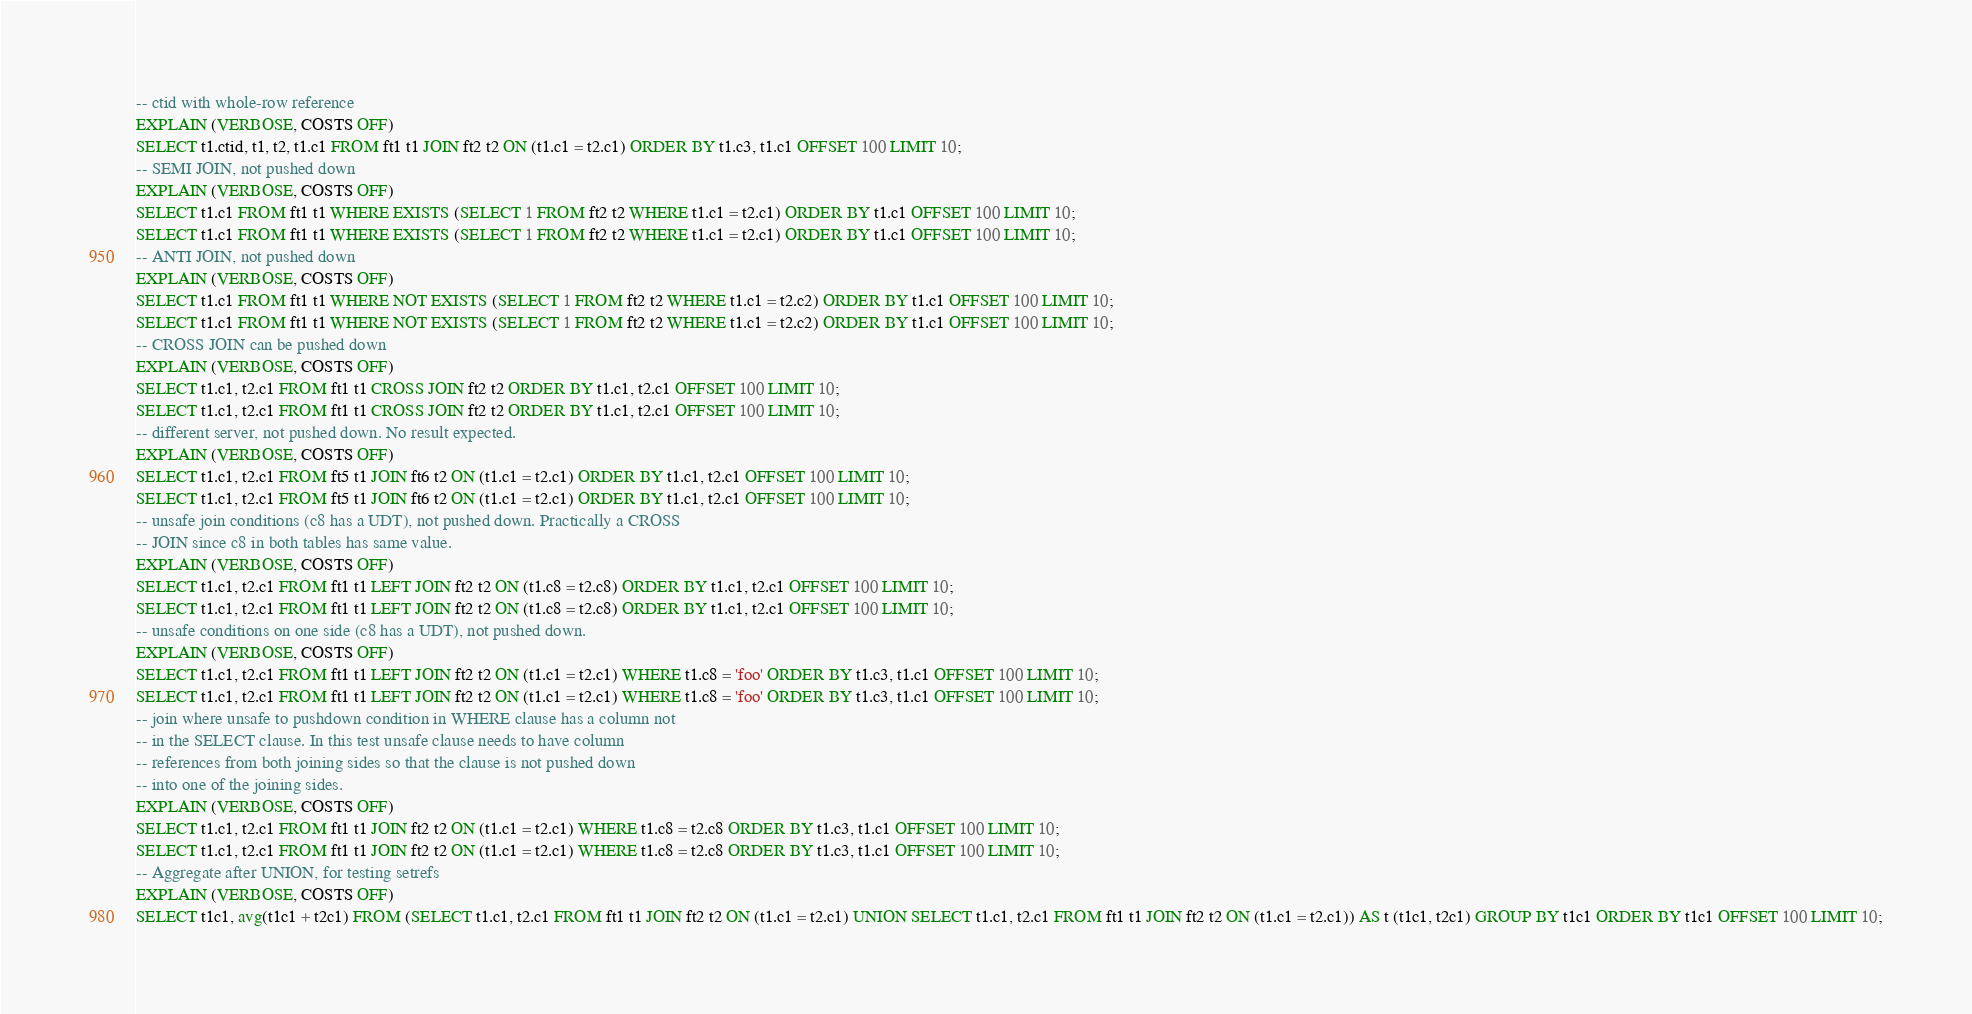<code> <loc_0><loc_0><loc_500><loc_500><_SQL_>-- ctid with whole-row reference
EXPLAIN (VERBOSE, COSTS OFF)
SELECT t1.ctid, t1, t2, t1.c1 FROM ft1 t1 JOIN ft2 t2 ON (t1.c1 = t2.c1) ORDER BY t1.c3, t1.c1 OFFSET 100 LIMIT 10;
-- SEMI JOIN, not pushed down
EXPLAIN (VERBOSE, COSTS OFF)
SELECT t1.c1 FROM ft1 t1 WHERE EXISTS (SELECT 1 FROM ft2 t2 WHERE t1.c1 = t2.c1) ORDER BY t1.c1 OFFSET 100 LIMIT 10;
SELECT t1.c1 FROM ft1 t1 WHERE EXISTS (SELECT 1 FROM ft2 t2 WHERE t1.c1 = t2.c1) ORDER BY t1.c1 OFFSET 100 LIMIT 10;
-- ANTI JOIN, not pushed down
EXPLAIN (VERBOSE, COSTS OFF)
SELECT t1.c1 FROM ft1 t1 WHERE NOT EXISTS (SELECT 1 FROM ft2 t2 WHERE t1.c1 = t2.c2) ORDER BY t1.c1 OFFSET 100 LIMIT 10;
SELECT t1.c1 FROM ft1 t1 WHERE NOT EXISTS (SELECT 1 FROM ft2 t2 WHERE t1.c1 = t2.c2) ORDER BY t1.c1 OFFSET 100 LIMIT 10;
-- CROSS JOIN can be pushed down
EXPLAIN (VERBOSE, COSTS OFF)
SELECT t1.c1, t2.c1 FROM ft1 t1 CROSS JOIN ft2 t2 ORDER BY t1.c1, t2.c1 OFFSET 100 LIMIT 10;
SELECT t1.c1, t2.c1 FROM ft1 t1 CROSS JOIN ft2 t2 ORDER BY t1.c1, t2.c1 OFFSET 100 LIMIT 10;
-- different server, not pushed down. No result expected.
EXPLAIN (VERBOSE, COSTS OFF)
SELECT t1.c1, t2.c1 FROM ft5 t1 JOIN ft6 t2 ON (t1.c1 = t2.c1) ORDER BY t1.c1, t2.c1 OFFSET 100 LIMIT 10;
SELECT t1.c1, t2.c1 FROM ft5 t1 JOIN ft6 t2 ON (t1.c1 = t2.c1) ORDER BY t1.c1, t2.c1 OFFSET 100 LIMIT 10;
-- unsafe join conditions (c8 has a UDT), not pushed down. Practically a CROSS
-- JOIN since c8 in both tables has same value.
EXPLAIN (VERBOSE, COSTS OFF)
SELECT t1.c1, t2.c1 FROM ft1 t1 LEFT JOIN ft2 t2 ON (t1.c8 = t2.c8) ORDER BY t1.c1, t2.c1 OFFSET 100 LIMIT 10;
SELECT t1.c1, t2.c1 FROM ft1 t1 LEFT JOIN ft2 t2 ON (t1.c8 = t2.c8) ORDER BY t1.c1, t2.c1 OFFSET 100 LIMIT 10;
-- unsafe conditions on one side (c8 has a UDT), not pushed down.
EXPLAIN (VERBOSE, COSTS OFF)
SELECT t1.c1, t2.c1 FROM ft1 t1 LEFT JOIN ft2 t2 ON (t1.c1 = t2.c1) WHERE t1.c8 = 'foo' ORDER BY t1.c3, t1.c1 OFFSET 100 LIMIT 10;
SELECT t1.c1, t2.c1 FROM ft1 t1 LEFT JOIN ft2 t2 ON (t1.c1 = t2.c1) WHERE t1.c8 = 'foo' ORDER BY t1.c3, t1.c1 OFFSET 100 LIMIT 10;
-- join where unsafe to pushdown condition in WHERE clause has a column not
-- in the SELECT clause. In this test unsafe clause needs to have column
-- references from both joining sides so that the clause is not pushed down
-- into one of the joining sides.
EXPLAIN (VERBOSE, COSTS OFF)
SELECT t1.c1, t2.c1 FROM ft1 t1 JOIN ft2 t2 ON (t1.c1 = t2.c1) WHERE t1.c8 = t2.c8 ORDER BY t1.c3, t1.c1 OFFSET 100 LIMIT 10;
SELECT t1.c1, t2.c1 FROM ft1 t1 JOIN ft2 t2 ON (t1.c1 = t2.c1) WHERE t1.c8 = t2.c8 ORDER BY t1.c3, t1.c1 OFFSET 100 LIMIT 10;
-- Aggregate after UNION, for testing setrefs
EXPLAIN (VERBOSE, COSTS OFF)
SELECT t1c1, avg(t1c1 + t2c1) FROM (SELECT t1.c1, t2.c1 FROM ft1 t1 JOIN ft2 t2 ON (t1.c1 = t2.c1) UNION SELECT t1.c1, t2.c1 FROM ft1 t1 JOIN ft2 t2 ON (t1.c1 = t2.c1)) AS t (t1c1, t2c1) GROUP BY t1c1 ORDER BY t1c1 OFFSET 100 LIMIT 10;</code> 